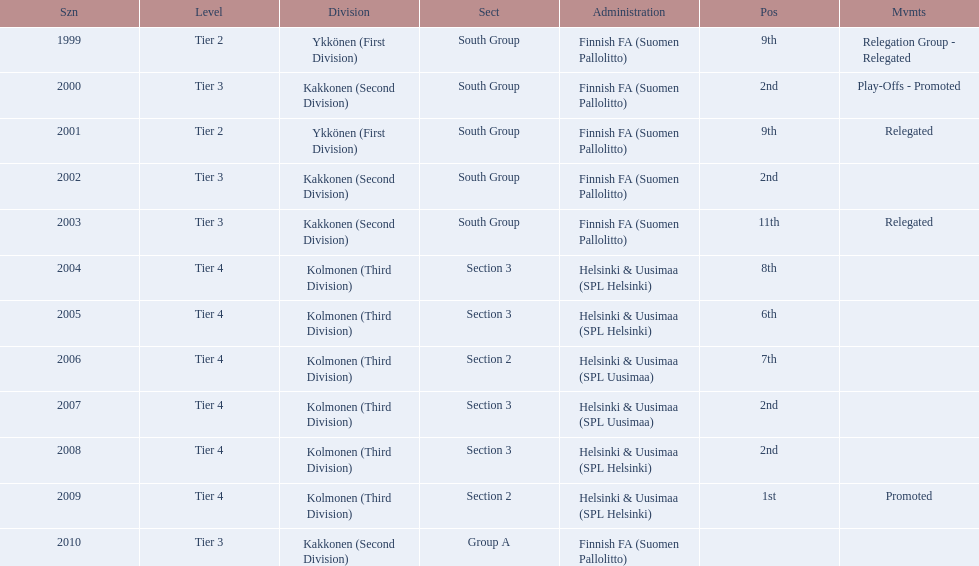Which administration has the least amount of division? Helsinki & Uusimaa (SPL Helsinki). 